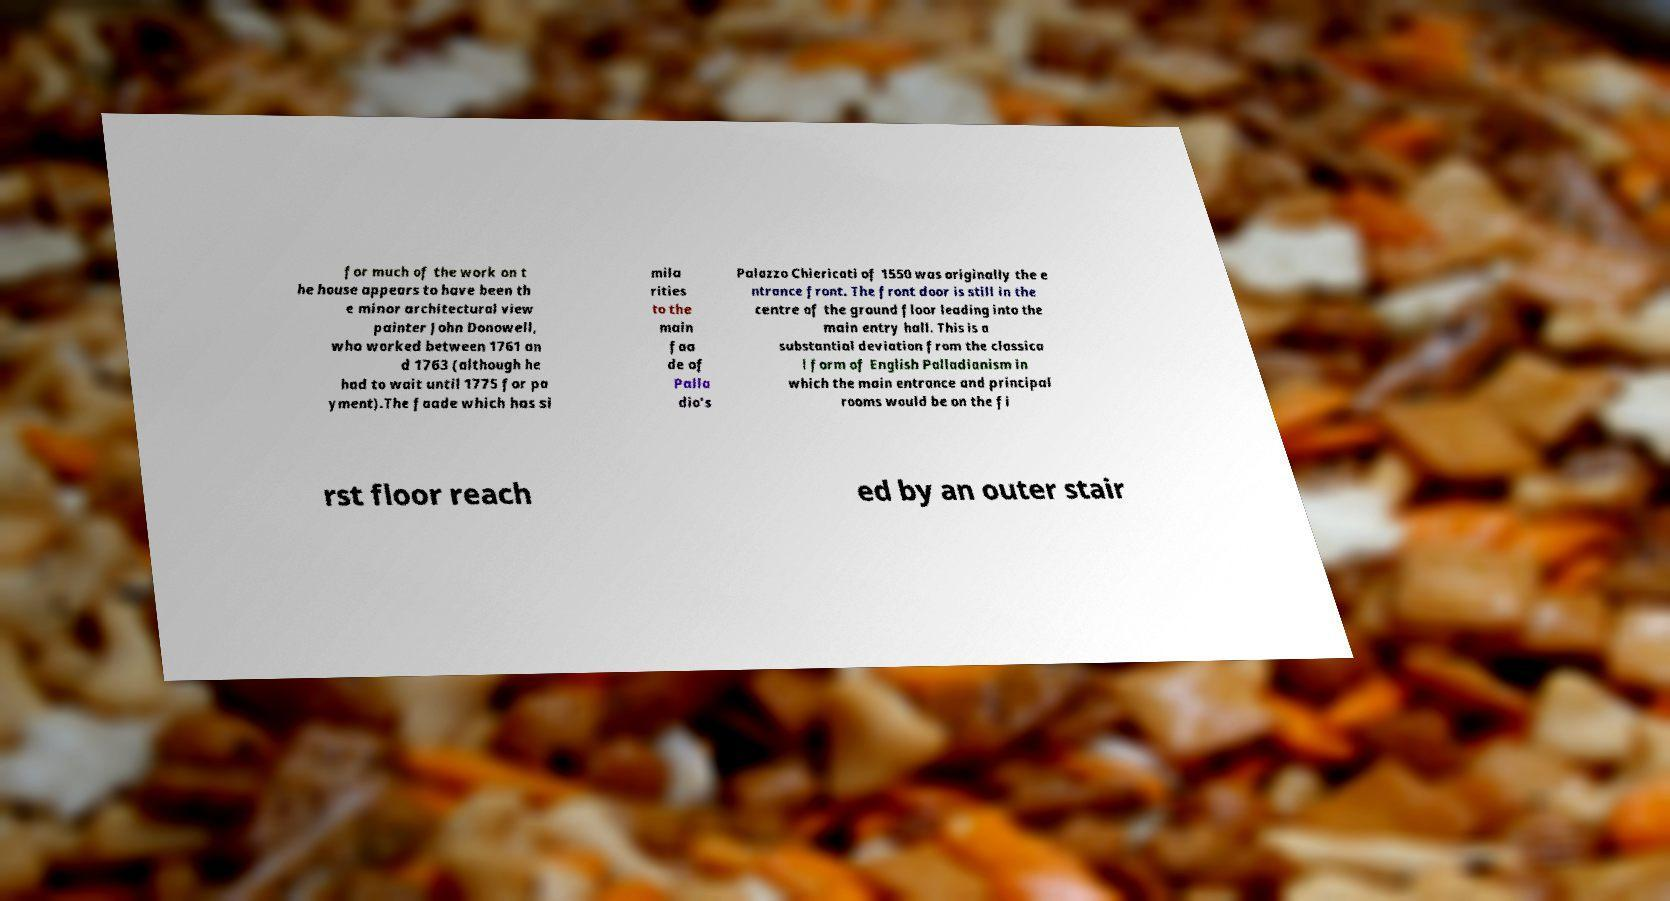Could you assist in decoding the text presented in this image and type it out clearly? for much of the work on t he house appears to have been th e minor architectural view painter John Donowell, who worked between 1761 an d 1763 (although he had to wait until 1775 for pa yment).The faade which has si mila rities to the main faa de of Palla dio's Palazzo Chiericati of 1550 was originally the e ntrance front. The front door is still in the centre of the ground floor leading into the main entry hall. This is a substantial deviation from the classica l form of English Palladianism in which the main entrance and principal rooms would be on the fi rst floor reach ed by an outer stair 